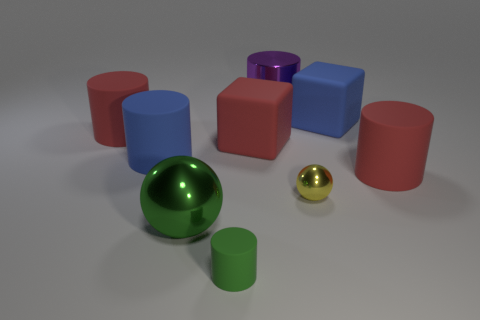Subtract all blue cylinders. How many cylinders are left? 4 Subtract all tiny cylinders. How many cylinders are left? 4 Subtract all yellow cylinders. Subtract all brown balls. How many cylinders are left? 5 Add 1 big cylinders. How many objects exist? 10 Subtract all spheres. How many objects are left? 7 Add 7 blue things. How many blue things are left? 9 Add 3 big green shiny things. How many big green shiny things exist? 4 Subtract 1 yellow balls. How many objects are left? 8 Subtract all large purple things. Subtract all big red things. How many objects are left? 5 